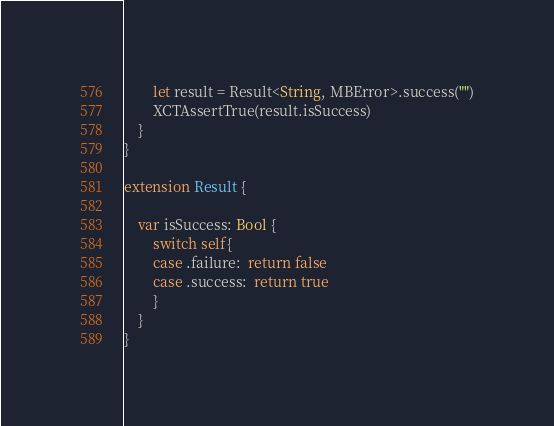Convert code to text. <code><loc_0><loc_0><loc_500><loc_500><_Swift_>        let result = Result<String, MBError>.success("")
        XCTAssertTrue(result.isSuccess)
	}
}

extension Result {
    
    var isSuccess: Bool {
        switch self{
        case .failure:  return false
        case .success:  return true
        }
    }
}
</code> 